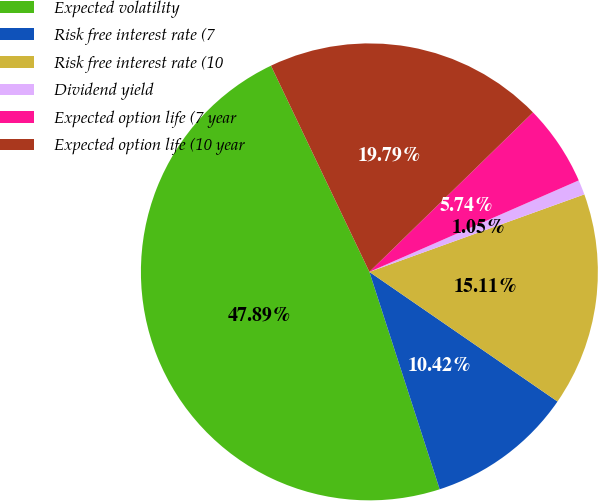Convert chart. <chart><loc_0><loc_0><loc_500><loc_500><pie_chart><fcel>Expected volatility<fcel>Risk free interest rate (7<fcel>Risk free interest rate (10<fcel>Dividend yield<fcel>Expected option life (7 year<fcel>Expected option life (10 year<nl><fcel>47.89%<fcel>10.42%<fcel>15.11%<fcel>1.05%<fcel>5.74%<fcel>19.79%<nl></chart> 